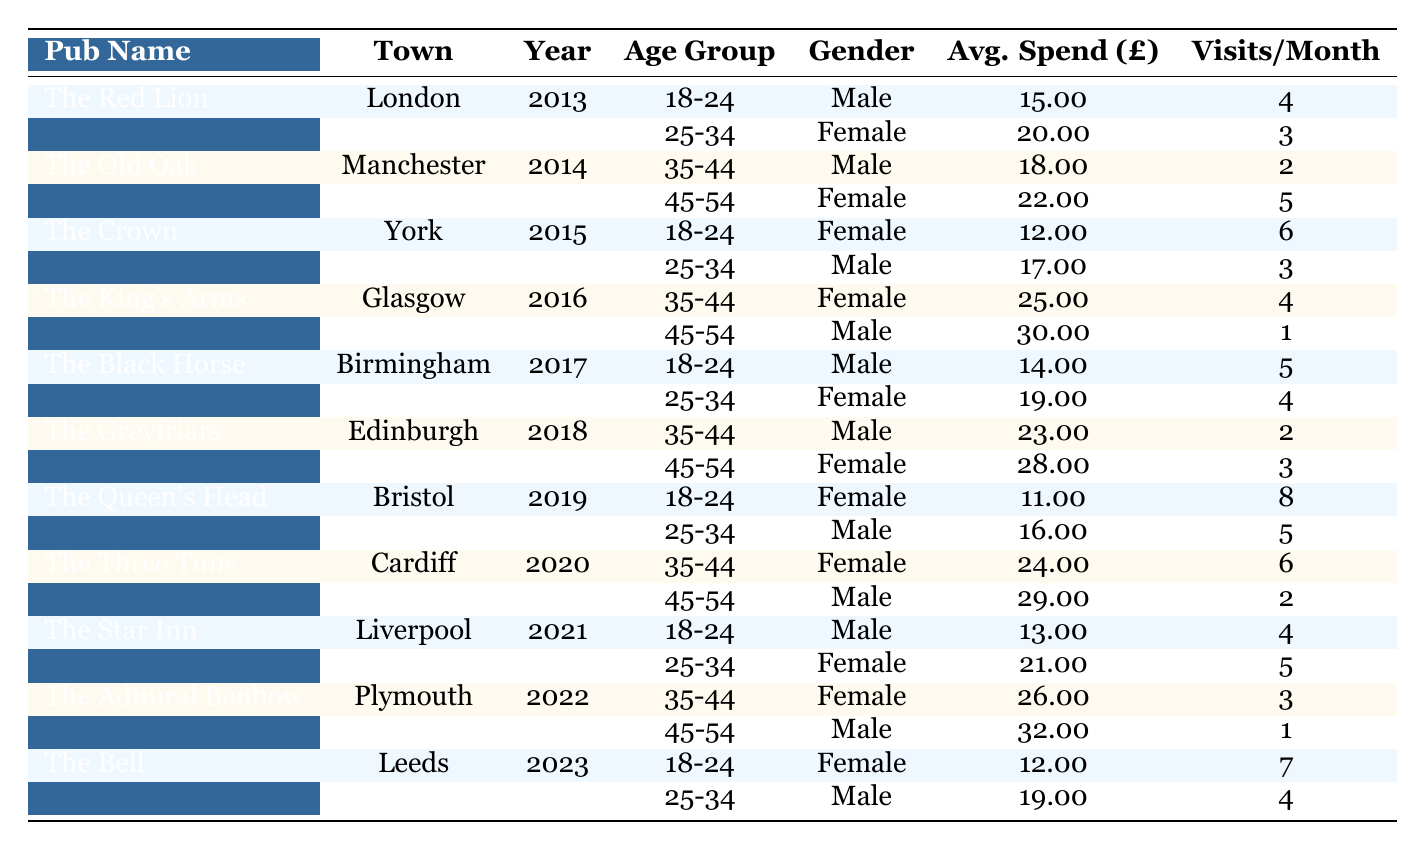What is the average spend per visit for patrons aged 25-34 at The King's Arms? At The King's Arms in 2016, there is one entry for patrons aged 25-34 who are female, with an average spend of £30.0, and one entry for male patrons aged 25-34 with an average spend of £17.0. Their average spend is (30 + 17)/2 = £24.50.
Answer: £24.50 What town is The Black Horse located in? The Black Horse is located in Birmingham, as stated in the corresponding entry in the table.
Answer: Birmingham Which pub had the highest average spend in 2022? In 2022, The Admiral Benbow had an average spend of £32 for male patrons aged 45-54, while The Star Inn had an average spend of £21 for female patrons aged 25-34. Therefore, The Admiral Benbow had the highest average spend for any patron in that year.
Answer: The Admiral Benbow How many visits per month do female patrons aged 18-24 make at The Queen's Head? At The Queen's Head in 2019, female patrons aged 18-24 have 8 visits per month, according to the entry in the table.
Answer: 8 Is the average spend for male patrons aged 35-44 at The Greyfriars lower than the average spend for female patrons in the same age group? The average spend for male patrons aged 35-44 at The Greyfriars in 2018 is £23, while for female patrons aged 35-44, the average spend is also £23. Therefore, the statement that male patrons have a lower average spend is false.
Answer: No What is the total number of visits per month for patrons aged 18-24 across all pubs in 2021? In 2021, the visits per month for patrons aged 18-24 are as follows: The Star Inn (4 visits). The total is 4 visits for this age group across the available data.
Answer: 4 Which gender had the highest average spend in traditional pubs in 2015? In 2015, The Crown had female patrons aged 18-24 with an average spend of £12 and male patrons aged 25-34 with an average spend of £17. This results in female patrons having a lower average spend than male patrons in all categories of 2015.
Answer: Male What is the average visits per month for all male patrons aged 45-54 across the years? The average visits for males aged 45-54 are: The Old Oak (5), The King's Arms (1), The Three Tuns (2), and The Admiral Benbow (1). The total is 5 + 1 + 2 + 1 = 9 visits over 4 entries yielding an average of 9/4 = 2.25 visits per month.
Answer: 2.25 Which pub recorded the highest average spend in 2018, and what was that amount? In 2018, The Greyfriars had male patrons aged 35-44 with an average spend of £23 and female patrons aged 45-54 with an average spend of £28. Thus, The Greyfriars recorded the highest average spend of £28.
Answer: The Greyfriars, £28 How much lower is the average spend of female patrons compared to male patrons aged 25-34 at The Black Horse? At The Black Horse in 2017, female patrons aged 25-34 had an average spend of £19, while male patrons had an average spend of £14. Therefore, the average spend of female patrons is higher by £5.
Answer: £5 In the last decade, did any pub show an increase in visits for the same age group consistently? From the available data, The Queen's Head in 2019 for young female patrons aged 18-24 had 8 visits and The Bell in 2023 also shows an increase in visits for females aged 18-24 with 7 visits, meaning there was an inconsistent tendency observed.
Answer: Yes 